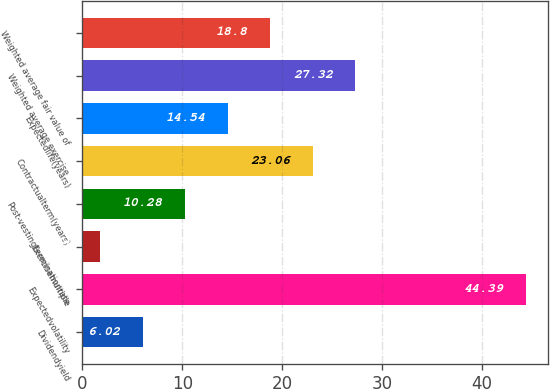Convert chart. <chart><loc_0><loc_0><loc_500><loc_500><bar_chart><fcel>Dividendyield<fcel>Expectedvolatility<fcel>Exercisemultiple<fcel>Post-vestingterminationrate<fcel>Contractualterm(years)<fcel>Expectedlife(years)<fcel>Weighted average exercise<fcel>Weighted average fair value of<nl><fcel>6.02<fcel>44.39<fcel>1.76<fcel>10.28<fcel>23.06<fcel>14.54<fcel>27.32<fcel>18.8<nl></chart> 